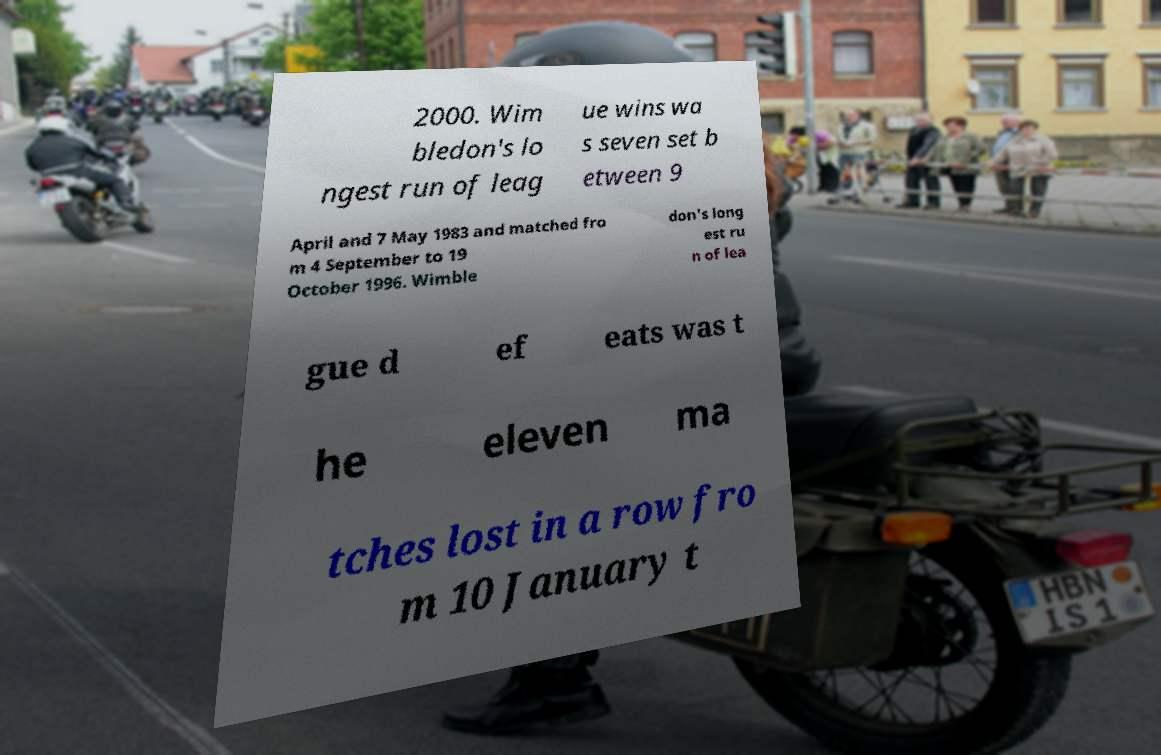I need the written content from this picture converted into text. Can you do that? 2000. Wim bledon's lo ngest run of leag ue wins wa s seven set b etween 9 April and 7 May 1983 and matched fro m 4 September to 19 October 1996. Wimble don's long est ru n of lea gue d ef eats was t he eleven ma tches lost in a row fro m 10 January t 